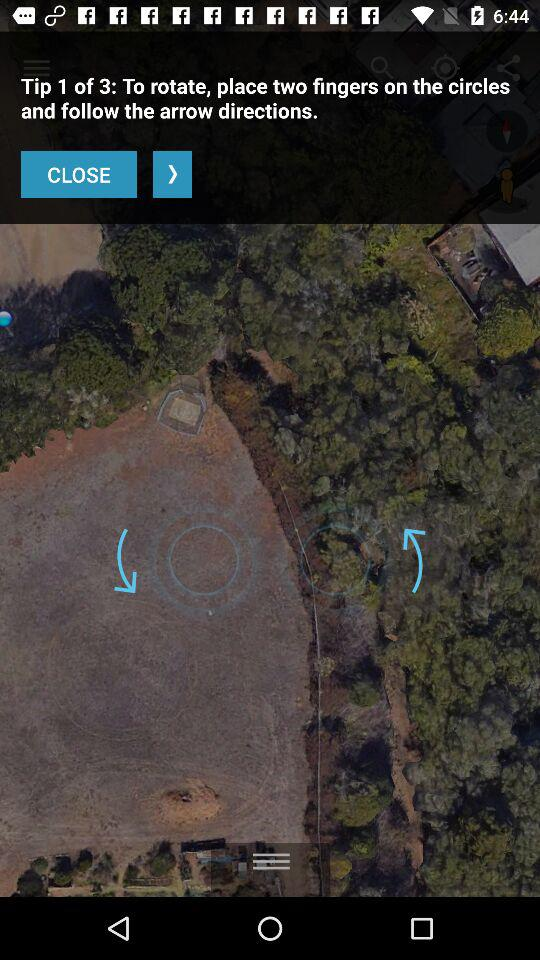How many tips in total are there? There are 3 tips. 